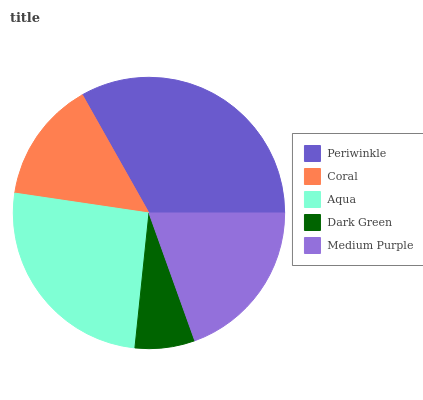Is Dark Green the minimum?
Answer yes or no. Yes. Is Periwinkle the maximum?
Answer yes or no. Yes. Is Coral the minimum?
Answer yes or no. No. Is Coral the maximum?
Answer yes or no. No. Is Periwinkle greater than Coral?
Answer yes or no. Yes. Is Coral less than Periwinkle?
Answer yes or no. Yes. Is Coral greater than Periwinkle?
Answer yes or no. No. Is Periwinkle less than Coral?
Answer yes or no. No. Is Medium Purple the high median?
Answer yes or no. Yes. Is Medium Purple the low median?
Answer yes or no. Yes. Is Dark Green the high median?
Answer yes or no. No. Is Periwinkle the low median?
Answer yes or no. No. 